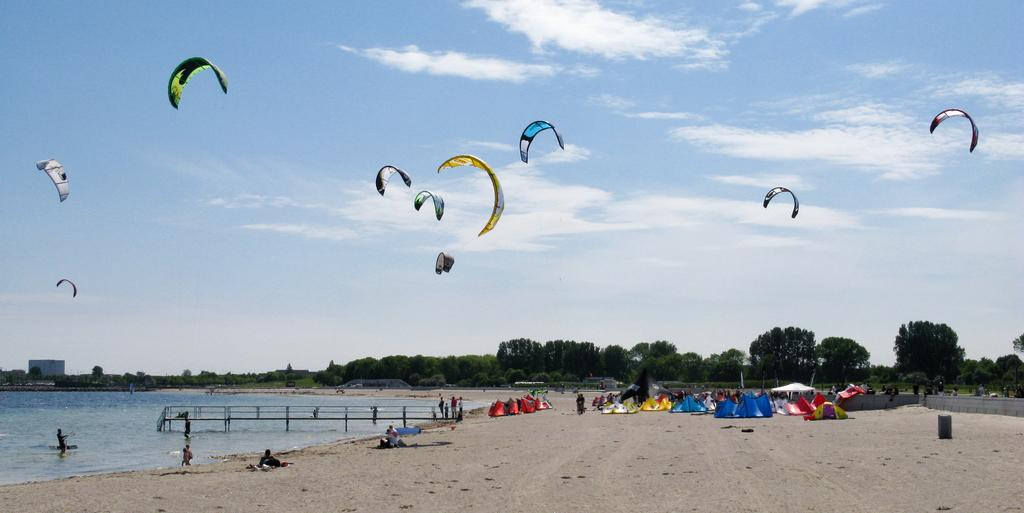What can be seen in the sky in the image? The sky is visible with clouds in the image. What are the parachutes doing in the image? The parachutes are in the air in the image. What type of vegetation is present in the image? There are trees in the image. What type of shelter is visible in the image? Tents are present in the image. Where are the persons standing in the image? Some persons are standing on the water, while others are standing on the seashore. What type of structure is visible in the image? A walkway bridge is visible in the image. What type of feast is being prepared in the image? There is no indication of a feast being prepared in the image. How many parents are visible in the image? There is no mention of parents in the image, as the focus is on parachutes, the sky, trees, tents, persons standing on water and seashore, and a walkway bridge. 